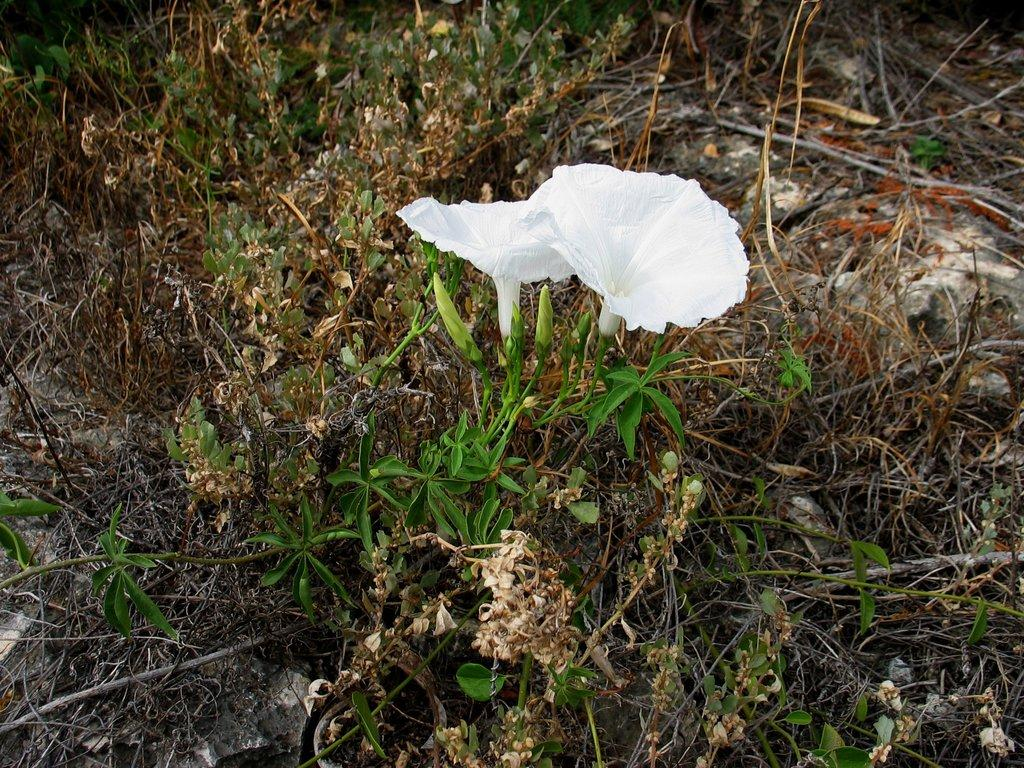What type of vegetation is in the front of the image? There are flowers in the front of the image. What type of vegetation is in the background of the image? There is dry grass in the background of the image. Are there any other plant-related elements in the image? Yes, there are leaves in the image. What type of whip can be seen in the image? There is no whip present in the image. How does the beginner use the calendar in the image? There is no calendar or beginner present in the image. 